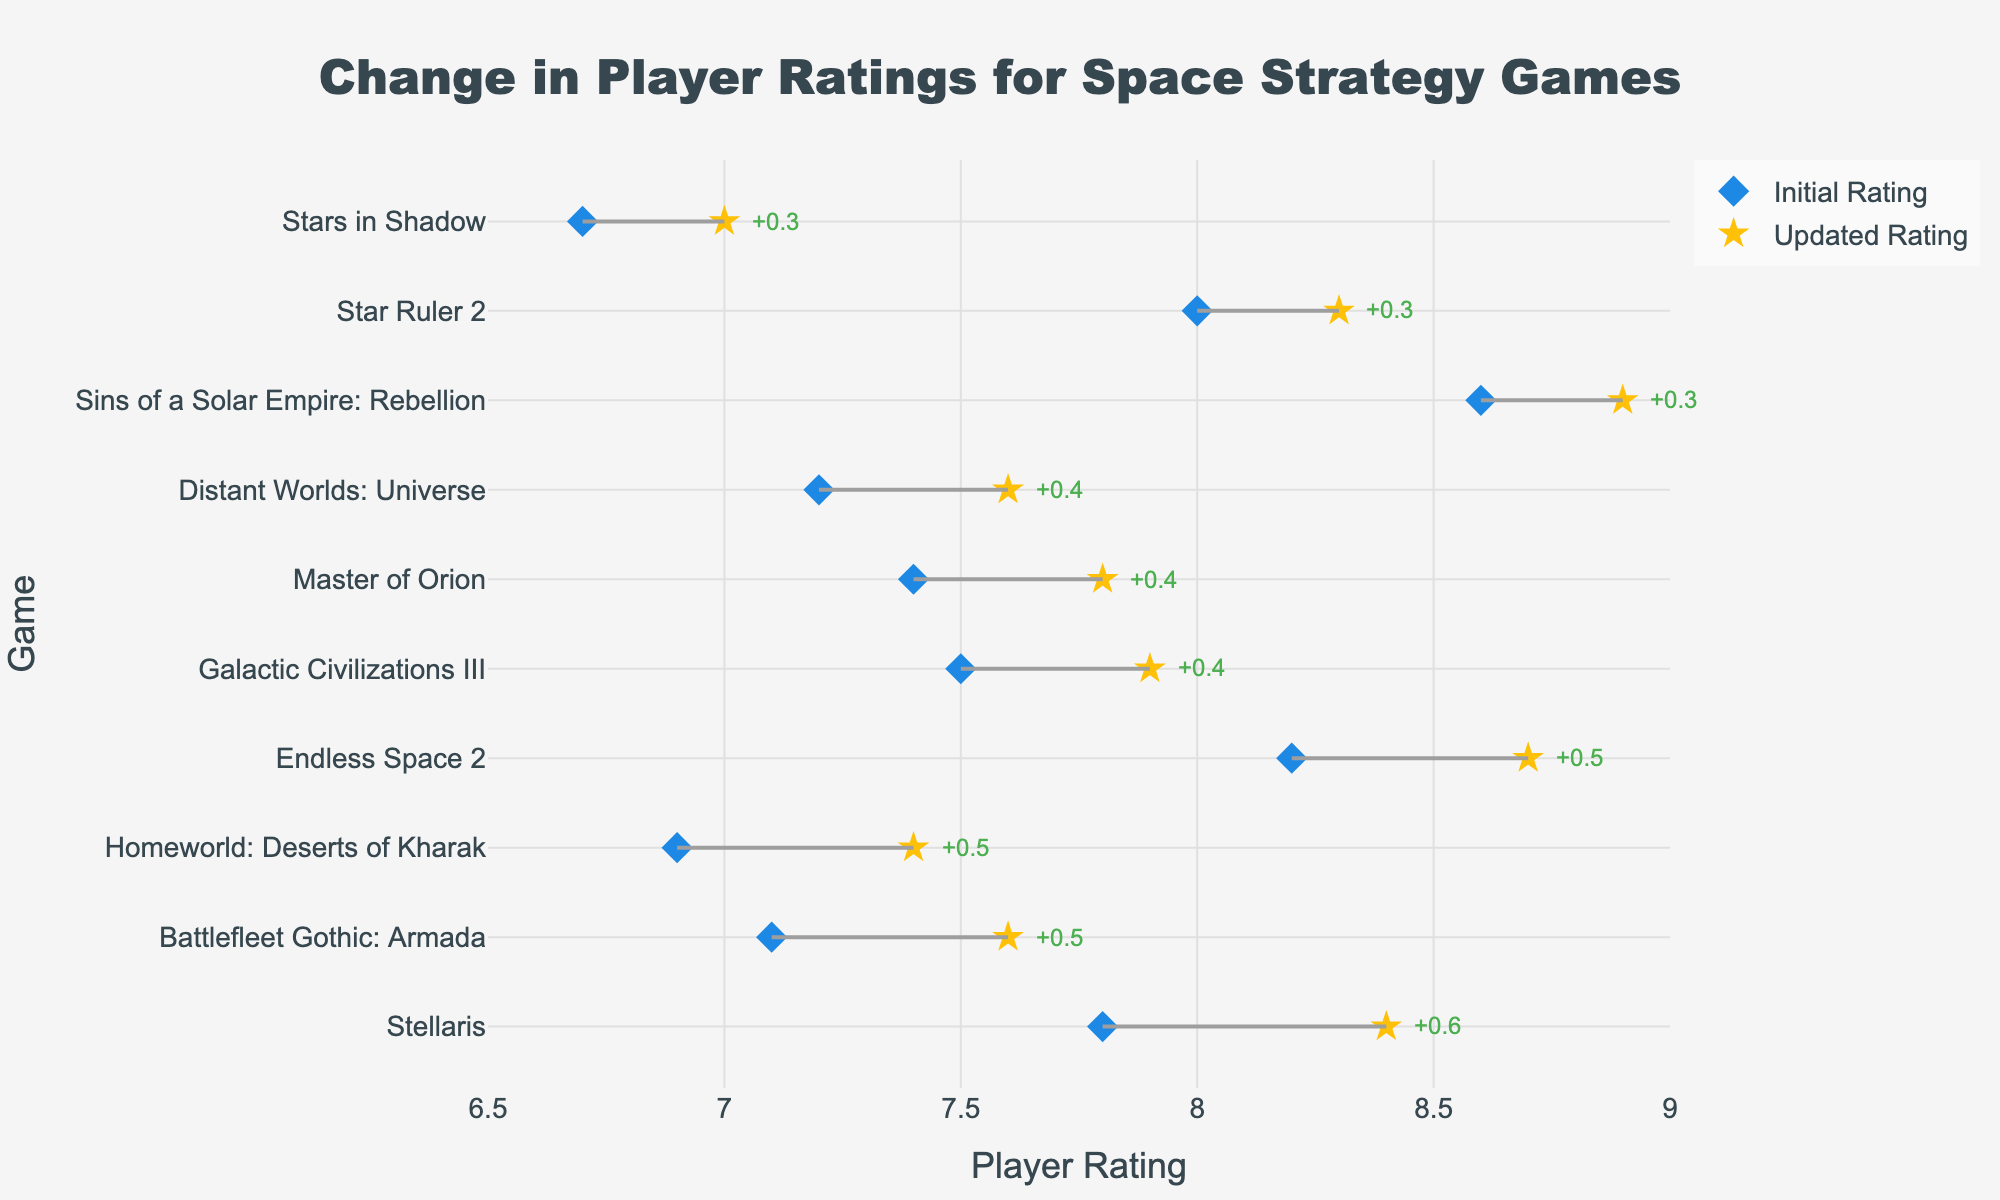What is the title of the plot? The title is located at the top of the plot and usually displayed prominently. In this plot, the title is "Change in Player Ratings for Space Strategy Games".
Answer: Change in Player Ratings for Space Strategy Games Which game has the highest initial rating? By looking at the leftmost points of the dumbbells (representing the initial ratings), the game with the highest initial rating is "Sins of a Solar Empire: Rebellion" with a rating of 8.6.
Answer: Sins of a Solar Empire: Rebellion Which game shows the greatest improvement in player rating after the update? To find the game with the greatest improvement, look for the longest line connecting the initial and updated ratings. This corresponds to "Endless Space 2", which improved from 8.2 to 8.7, a difference of 0.5.
Answer: Endless Space 2 What is the average initial rating of all the games? Add all the initial ratings and divide by the number of games. The sum of initial ratings is \(7.8 + 8.2 + 7.5 + 6.9 + 8.0 + 8.6 + 7.2 + 6.7 + 7.4 + 7.1 = 75.4\). There are 10 games, so the average is \(75.4 / 10 = 7.54\).
Answer: 7.54 Is there any game that has an equal initial and updated rating? Check each pair of initial and updated ratings to see if they are equal. In this case, no game has an equal initial and updated rating.
Answer: No Which game has the smallest improvement in player rating? The smallest improvement will have the shortest line connecting the initial and updated ratings. "Stars in Shadow" has the smallest improvement, from 6.7 to 7.0, a difference of 0.3.
Answer: Stars in Shadow How many games have an initial rating below 7.0? Count the games that have initial ratings under 7.0. They are "Homeworld: Deserts of Kharak" (6.9) and "Stars in Shadow" (6.7), so there are 2.
Answer: 2 What is the increase in player rating for "Master of Orion"? Locate "Master of Orion" on the y-axis, then check the initial and updated ratings. The initial rating is 7.4, and the updated rating is 7.8. The increase is \(7.8 - 7.4 = 0.4\).
Answer: 0.4 Which game has the highest updated rating? By examining the rightmost points of the dumbbells, the game with the highest updated rating is "Sins of a Solar Empire: Rebellion" with a rating of 8.9.
Answer: Sins of a Solar Empire: Rebellion 